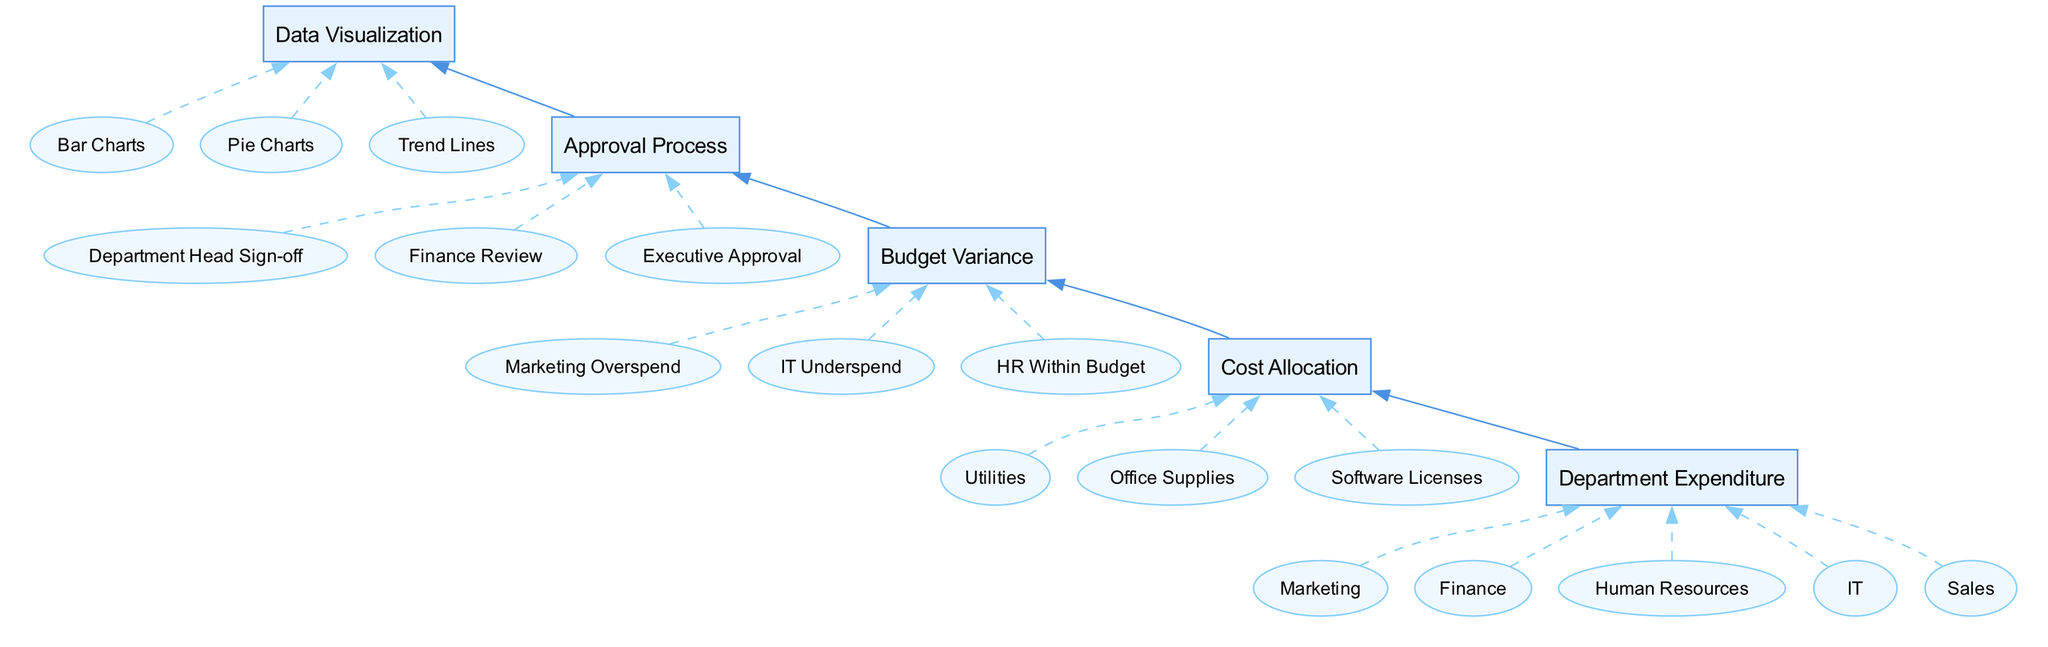What is the first node in the diagram? The first node, located at the bottom of the flow, is "Department Expenditure." This node represents the starting point for the flow of information regarding the yearly expense report.
Answer: Department Expenditure How many examples are provided for "Cost Allocation"? In the diagram, there are three examples listed for "Cost Allocation": Utilities, Office Supplies, and Software Licenses. Counting these gives a total of three examples.
Answer: Three What node directly follows "Budget Variance"? The node that follows "Budget Variance" in the flow is "Approval Process." This indicates the sequence in which the budget variance leads to an approval workflow for expenses.
Answer: Approval Process Which two nodes are connected directly? The nodes "Department Expenditure" and "Cost Allocation" are connected directly. This shows that the total spending by each department leads to the distribution of shared costs among them.
Answer: Department Expenditure, Cost Allocation What is the relationship between "Cost Allocation" and "Data Visualization"? The relationship is that "Cost Allocation" leads into "Budget Variance," which then leads to "Approval Process," ultimately connecting to "Data Visualization." This indicates a flow from cost distribution to graphical financial data representation.
Answer: Sequential Which department example is listed under "Department Expenditure"? One of the examples for "Department Expenditure" is "Marketing." This suggests that Marketing is one of the departments tracked for their expenditures in the report.
Answer: Marketing What type of chart is mentioned under "Data Visualization"? The type of chart mentioned under "Data Visualization" as a graphical representation of financial data is "Bar Charts." This indicates a specific method of visualizing the data.
Answer: Bar Charts How many total elements are present in the diagram? There are five total elements present in the diagram: Department Expenditure, Cost Allocation, Budget Variance, Approval Process, and Data Visualization. Therefore, counting all elements gives us five.
Answer: Five What is the flow direction of the relationships depicted in the diagram? The flow direction in the diagram is from the bottom up, starting at "Department Expenditure" and moving towards "Data Visualization." This indicates a sequential build-up of information.
Answer: Bottom Up 